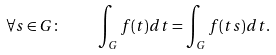Convert formula to latex. <formula><loc_0><loc_0><loc_500><loc_500>\forall s \in G \colon \quad \int _ { G } f ( t ) d t = \int _ { G } f ( t s ) d t .</formula> 